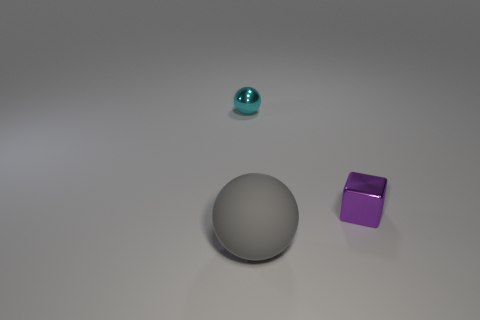Are there any other things that are made of the same material as the big gray object?
Provide a succinct answer. No. What material is the thing that is the same size as the cyan sphere?
Offer a very short reply. Metal. There is a sphere that is left of the sphere that is in front of the small metallic thing that is in front of the tiny cyan metal thing; how big is it?
Provide a short and direct response. Small. How many other things are made of the same material as the gray sphere?
Your answer should be compact. 0. How big is the thing in front of the block?
Provide a short and direct response. Large. How many spheres are in front of the tiny purple metallic cube and behind the rubber ball?
Offer a very short reply. 0. There is a thing that is left of the ball right of the small cyan ball; what is its material?
Your response must be concise. Metal. There is another small object that is the same shape as the rubber object; what is its material?
Your answer should be compact. Metal. Is there a small cyan thing?
Your answer should be very brief. Yes. There is a object that is the same material as the small sphere; what shape is it?
Offer a terse response. Cube. 